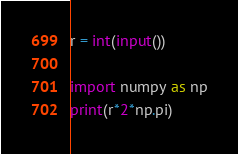<code> <loc_0><loc_0><loc_500><loc_500><_Python_>r = int(input())

import numpy as np
print(r*2*np.pi)</code> 